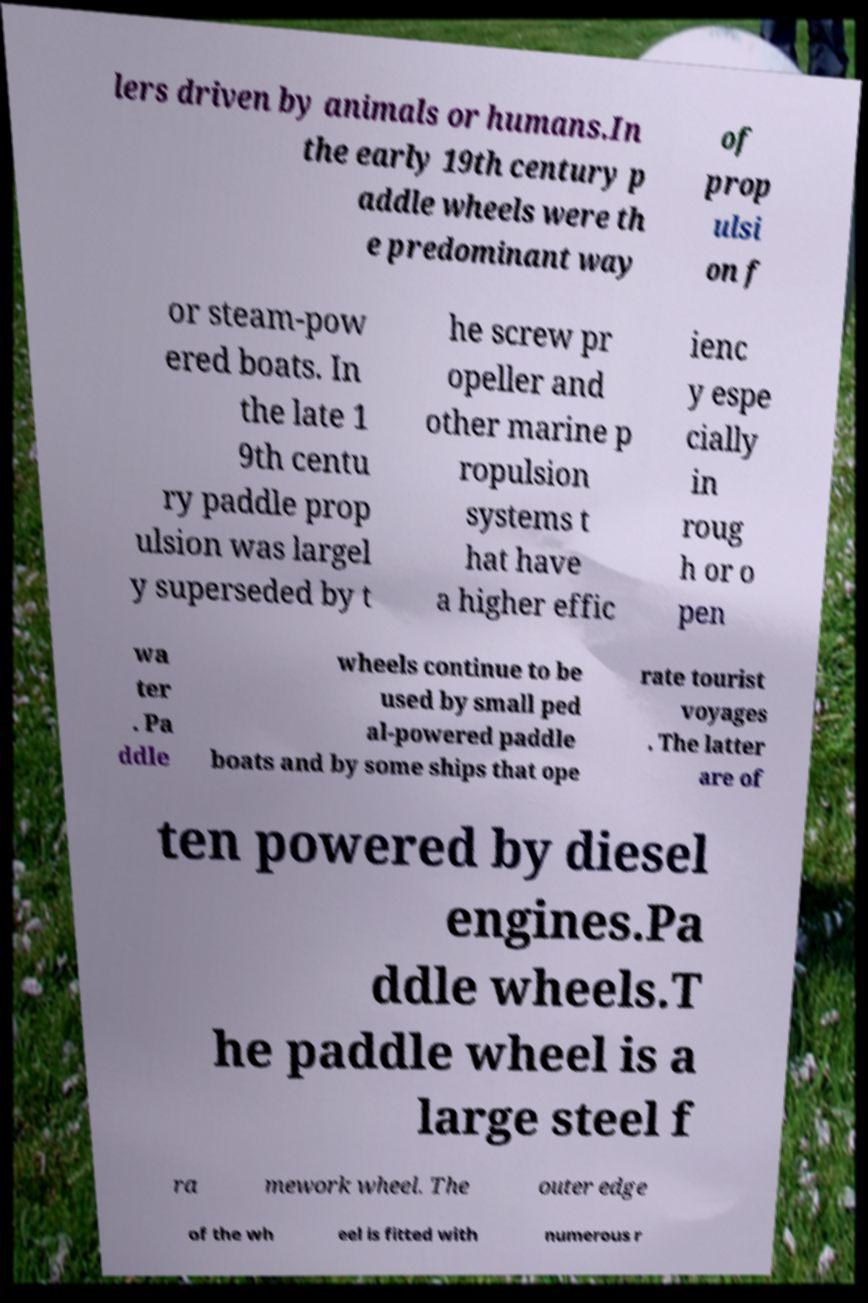For documentation purposes, I need the text within this image transcribed. Could you provide that? lers driven by animals or humans.In the early 19th century p addle wheels were th e predominant way of prop ulsi on f or steam-pow ered boats. In the late 1 9th centu ry paddle prop ulsion was largel y superseded by t he screw pr opeller and other marine p ropulsion systems t hat have a higher effic ienc y espe cially in roug h or o pen wa ter . Pa ddle wheels continue to be used by small ped al-powered paddle boats and by some ships that ope rate tourist voyages . The latter are of ten powered by diesel engines.Pa ddle wheels.T he paddle wheel is a large steel f ra mework wheel. The outer edge of the wh eel is fitted with numerous r 